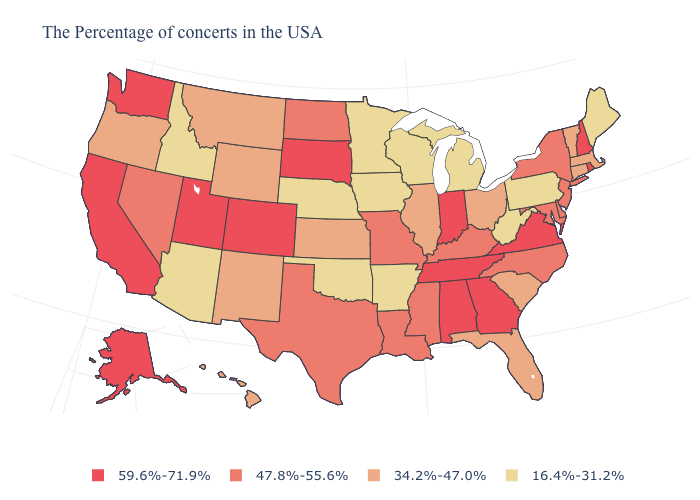What is the highest value in states that border Kentucky?
Give a very brief answer. 59.6%-71.9%. What is the value of Washington?
Quick response, please. 59.6%-71.9%. Does the map have missing data?
Concise answer only. No. Which states have the lowest value in the Northeast?
Quick response, please. Maine, Pennsylvania. What is the lowest value in states that border New Hampshire?
Be succinct. 16.4%-31.2%. What is the value of Oregon?
Give a very brief answer. 34.2%-47.0%. What is the lowest value in states that border Washington?
Answer briefly. 16.4%-31.2%. Which states have the lowest value in the Northeast?
Keep it brief. Maine, Pennsylvania. Name the states that have a value in the range 47.8%-55.6%?
Concise answer only. New York, New Jersey, Delaware, Maryland, North Carolina, Kentucky, Mississippi, Louisiana, Missouri, Texas, North Dakota, Nevada. Which states hav the highest value in the South?
Keep it brief. Virginia, Georgia, Alabama, Tennessee. Which states hav the highest value in the Northeast?
Write a very short answer. Rhode Island, New Hampshire. Which states have the highest value in the USA?
Answer briefly. Rhode Island, New Hampshire, Virginia, Georgia, Indiana, Alabama, Tennessee, South Dakota, Colorado, Utah, California, Washington, Alaska. What is the lowest value in the West?
Write a very short answer. 16.4%-31.2%. What is the value of Tennessee?
Quick response, please. 59.6%-71.9%. Which states have the lowest value in the USA?
Be succinct. Maine, Pennsylvania, West Virginia, Michigan, Wisconsin, Arkansas, Minnesota, Iowa, Nebraska, Oklahoma, Arizona, Idaho. 